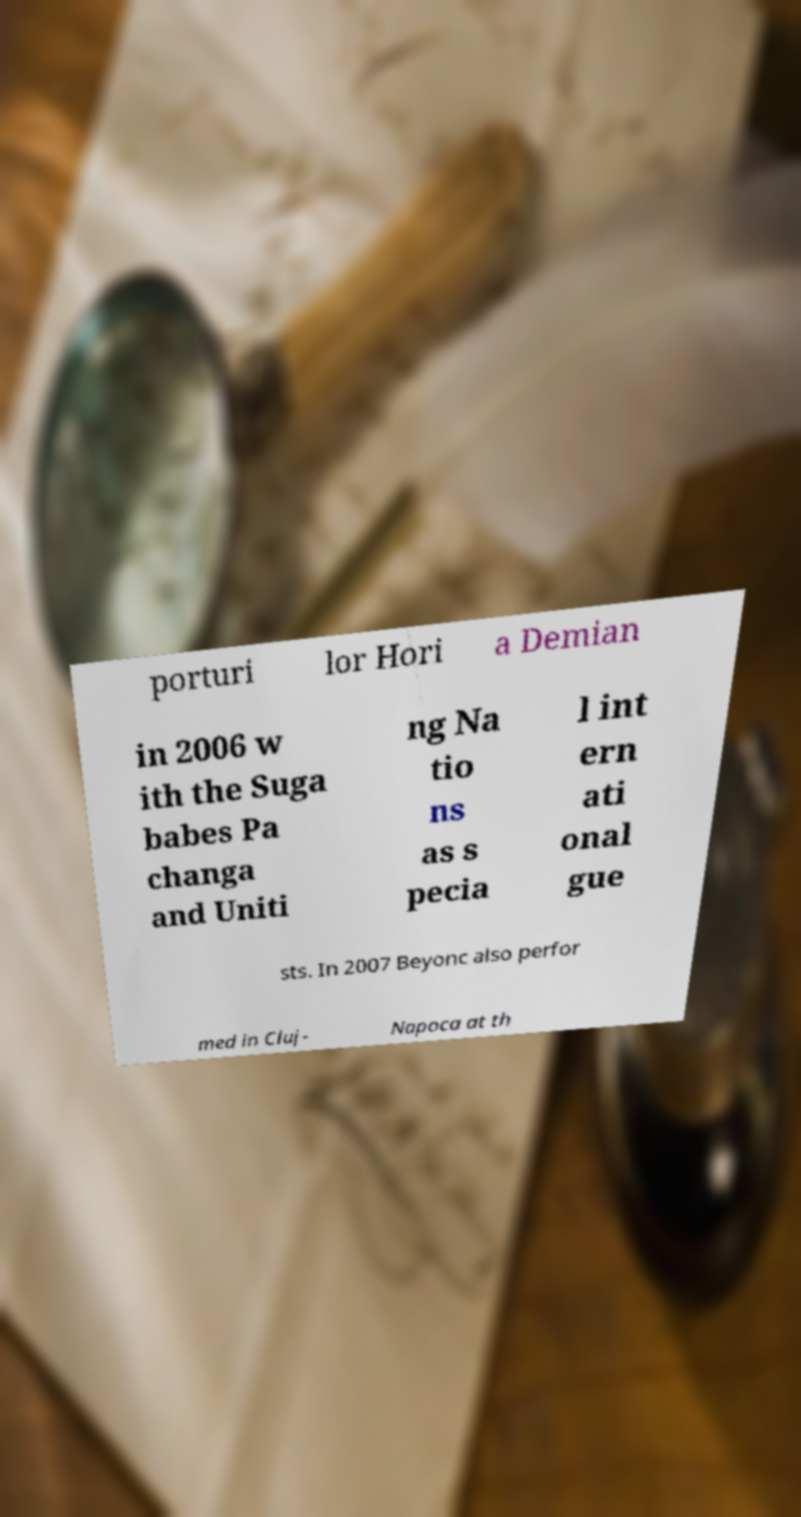There's text embedded in this image that I need extracted. Can you transcribe it verbatim? porturi lor Hori a Demian in 2006 w ith the Suga babes Pa changa and Uniti ng Na tio ns as s pecia l int ern ati onal gue sts. In 2007 Beyonc also perfor med in Cluj- Napoca at th 